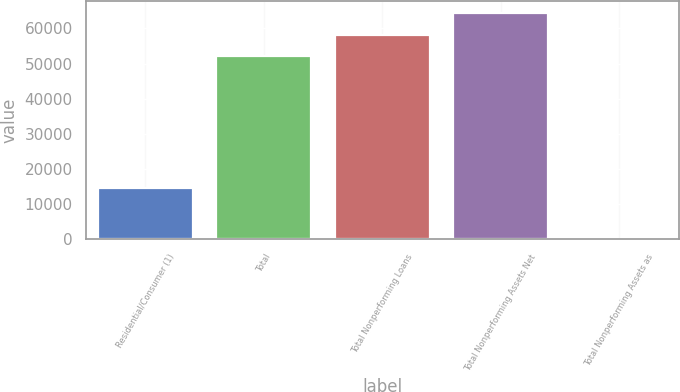<chart> <loc_0><loc_0><loc_500><loc_500><bar_chart><fcel>Residential/Consumer (1)<fcel>Total<fcel>Total Nonperforming Loans<fcel>Total Nonperforming Assets Net<fcel>Total Nonperforming Assets as<nl><fcel>14571<fcel>52033<fcel>58263.7<fcel>64494.4<fcel>0.88<nl></chart> 